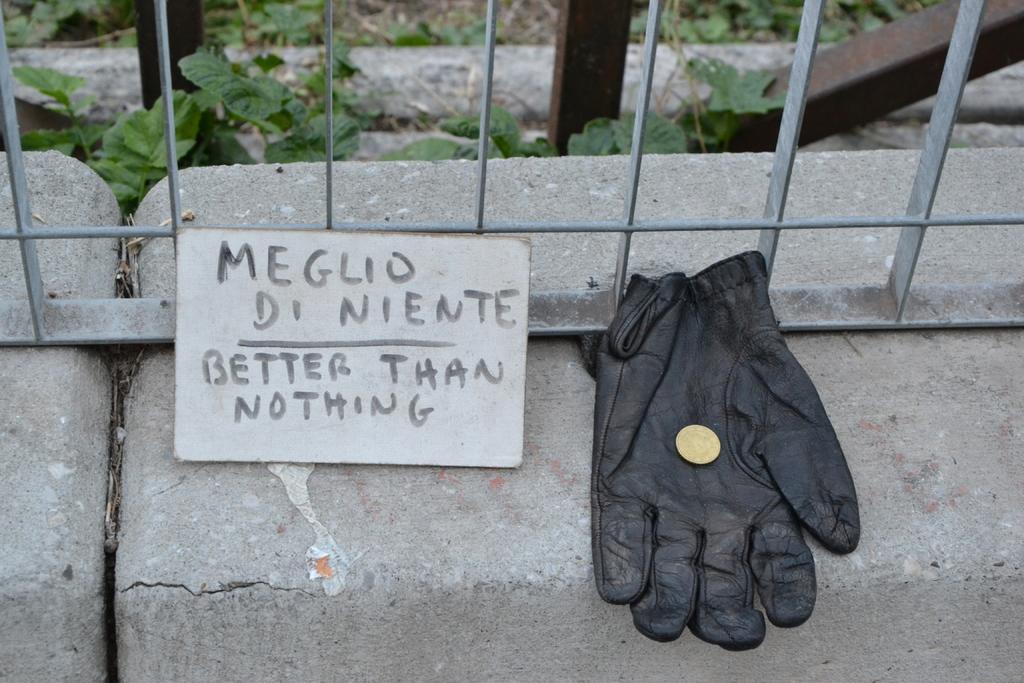In one or two sentences, can you explain what this image depicts? In this picture we can see a glove with a coin on it, name board, rods, stones and in the background we can see leaves. 